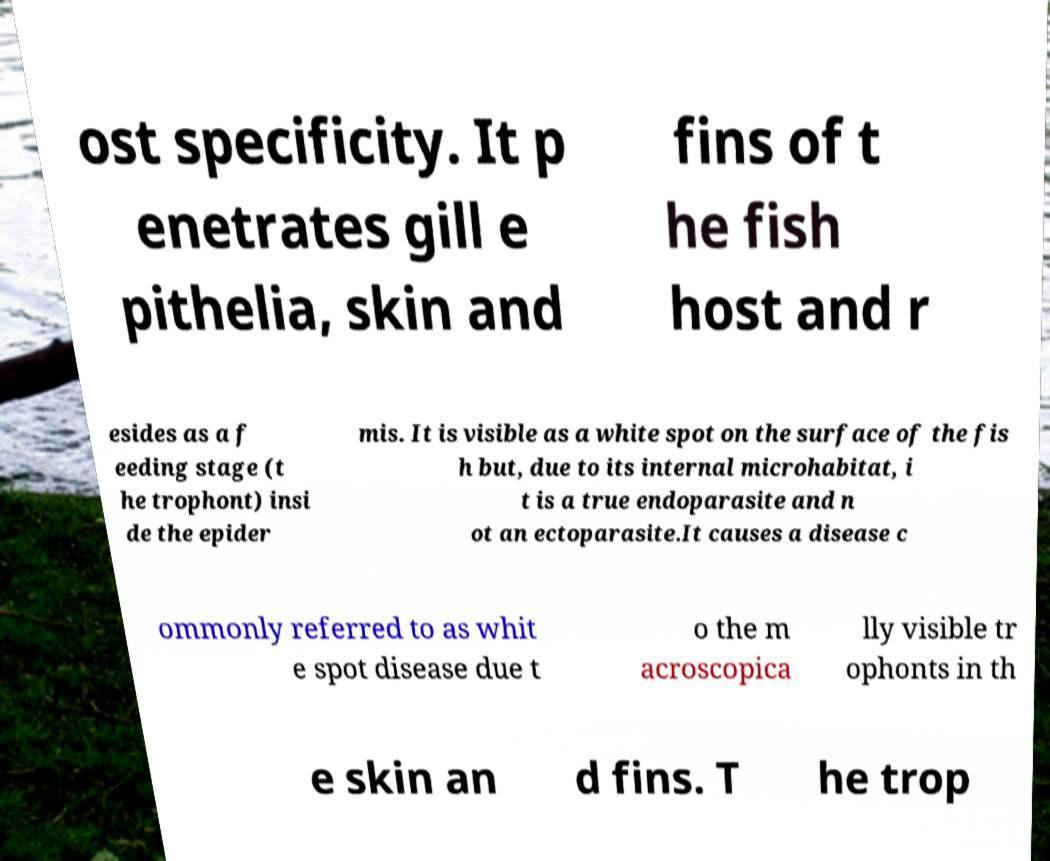What messages or text are displayed in this image? I need them in a readable, typed format. ost specificity. It p enetrates gill e pithelia, skin and fins of t he fish host and r esides as a f eeding stage (t he trophont) insi de the epider mis. It is visible as a white spot on the surface of the fis h but, due to its internal microhabitat, i t is a true endoparasite and n ot an ectoparasite.It causes a disease c ommonly referred to as whit e spot disease due t o the m acroscopica lly visible tr ophonts in th e skin an d fins. T he trop 